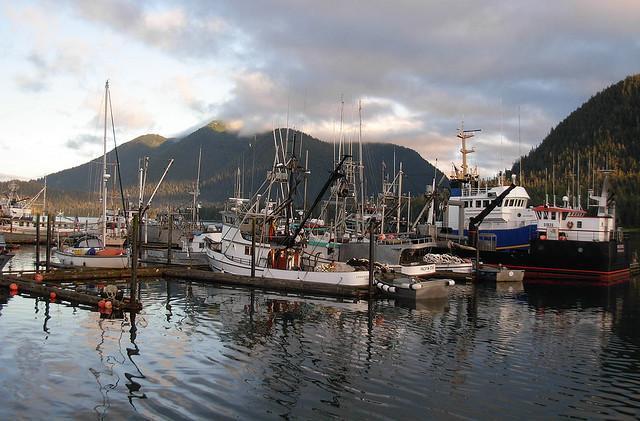What color are the lateral stripes wrapped around the black bodied boat?
Choose the correct response and explain in the format: 'Answer: answer
Rationale: rationale.'
Options: Orange, red, white, yellow. Answer: red.
Rationale: The black boat is clearly visible and the trim colors can been seen and identified. 